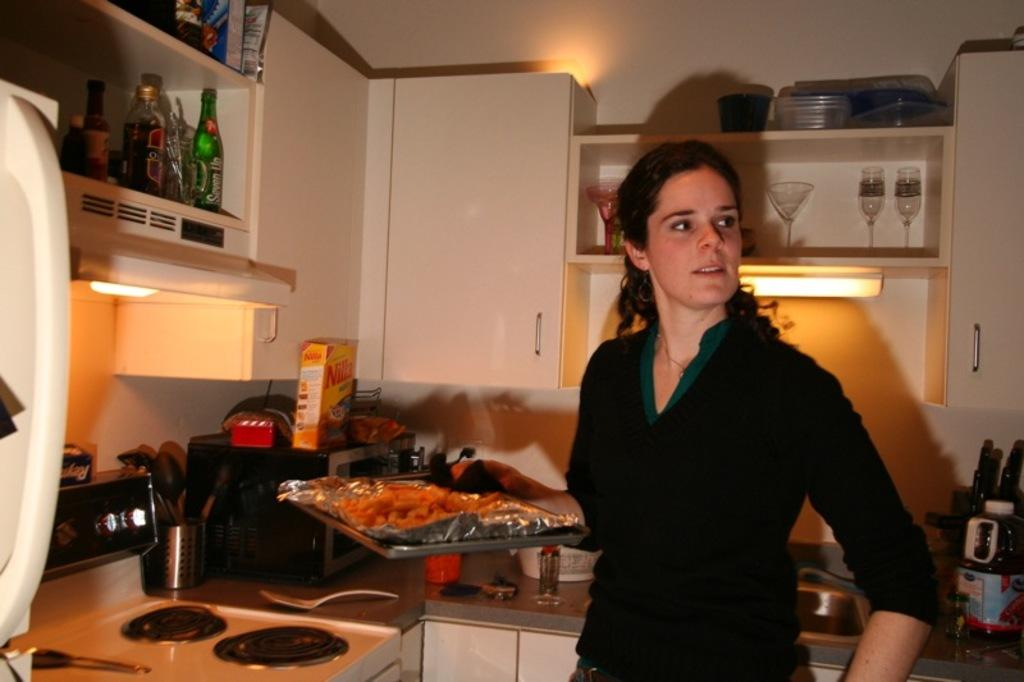<image>
Summarize the visual content of the image. A woman wearing black stands in her kitchen near a box of Nilla Wafers 